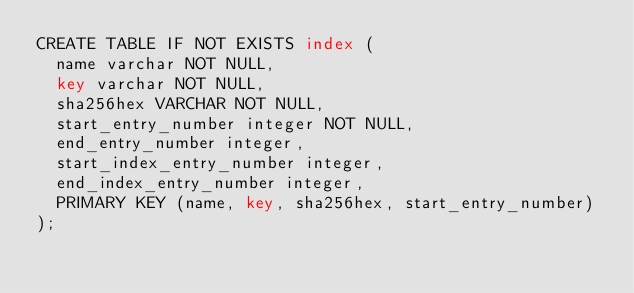<code> <loc_0><loc_0><loc_500><loc_500><_SQL_>CREATE TABLE IF NOT EXISTS index (
  name varchar NOT NULL,
  key varchar NOT NULL,
  sha256hex VARCHAR NOT NULL,
  start_entry_number integer NOT NULL,
  end_entry_number integer,
  start_index_entry_number integer,
  end_index_entry_number integer,
  PRIMARY KEY (name, key, sha256hex, start_entry_number)
);
</code> 